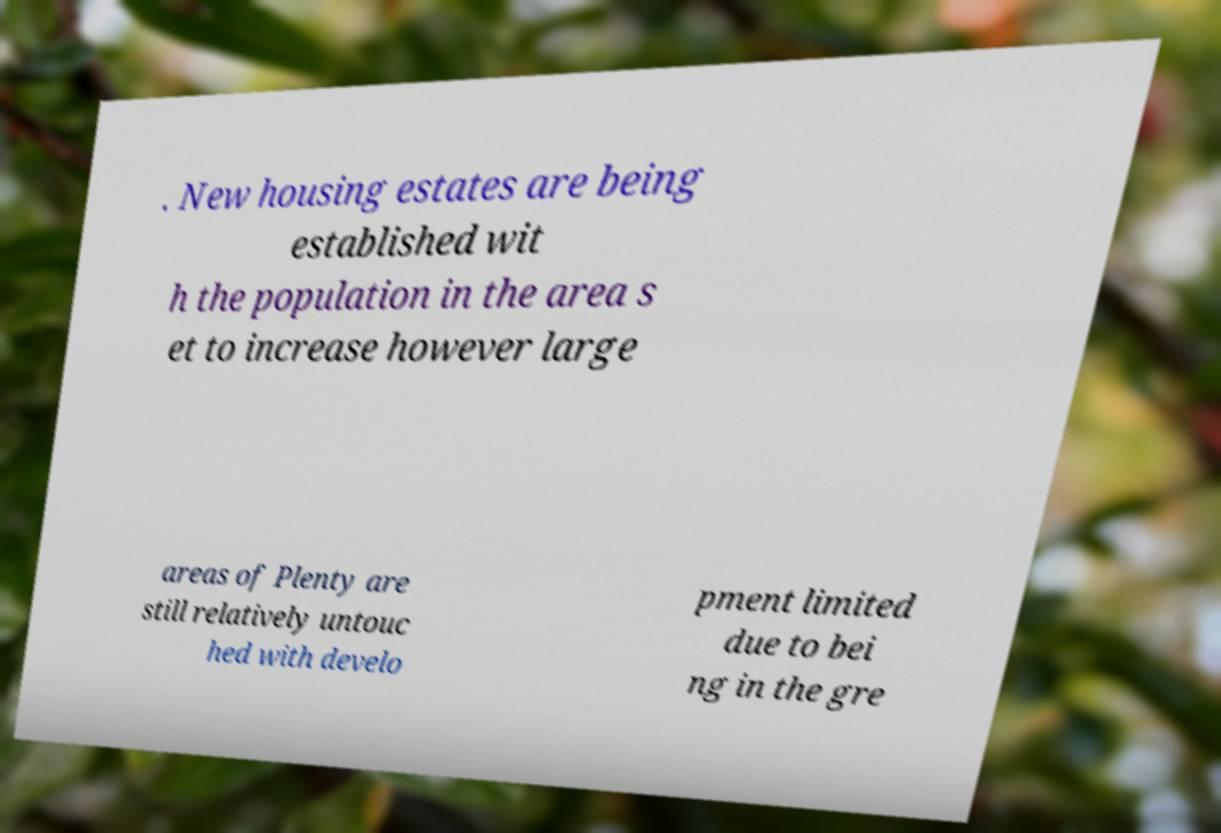Can you read and provide the text displayed in the image?This photo seems to have some interesting text. Can you extract and type it out for me? . New housing estates are being established wit h the population in the area s et to increase however large areas of Plenty are still relatively untouc hed with develo pment limited due to bei ng in the gre 